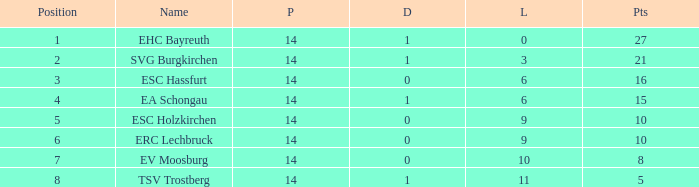What's the lost when there were more than 16 points and had a drawn less than 1? None. 